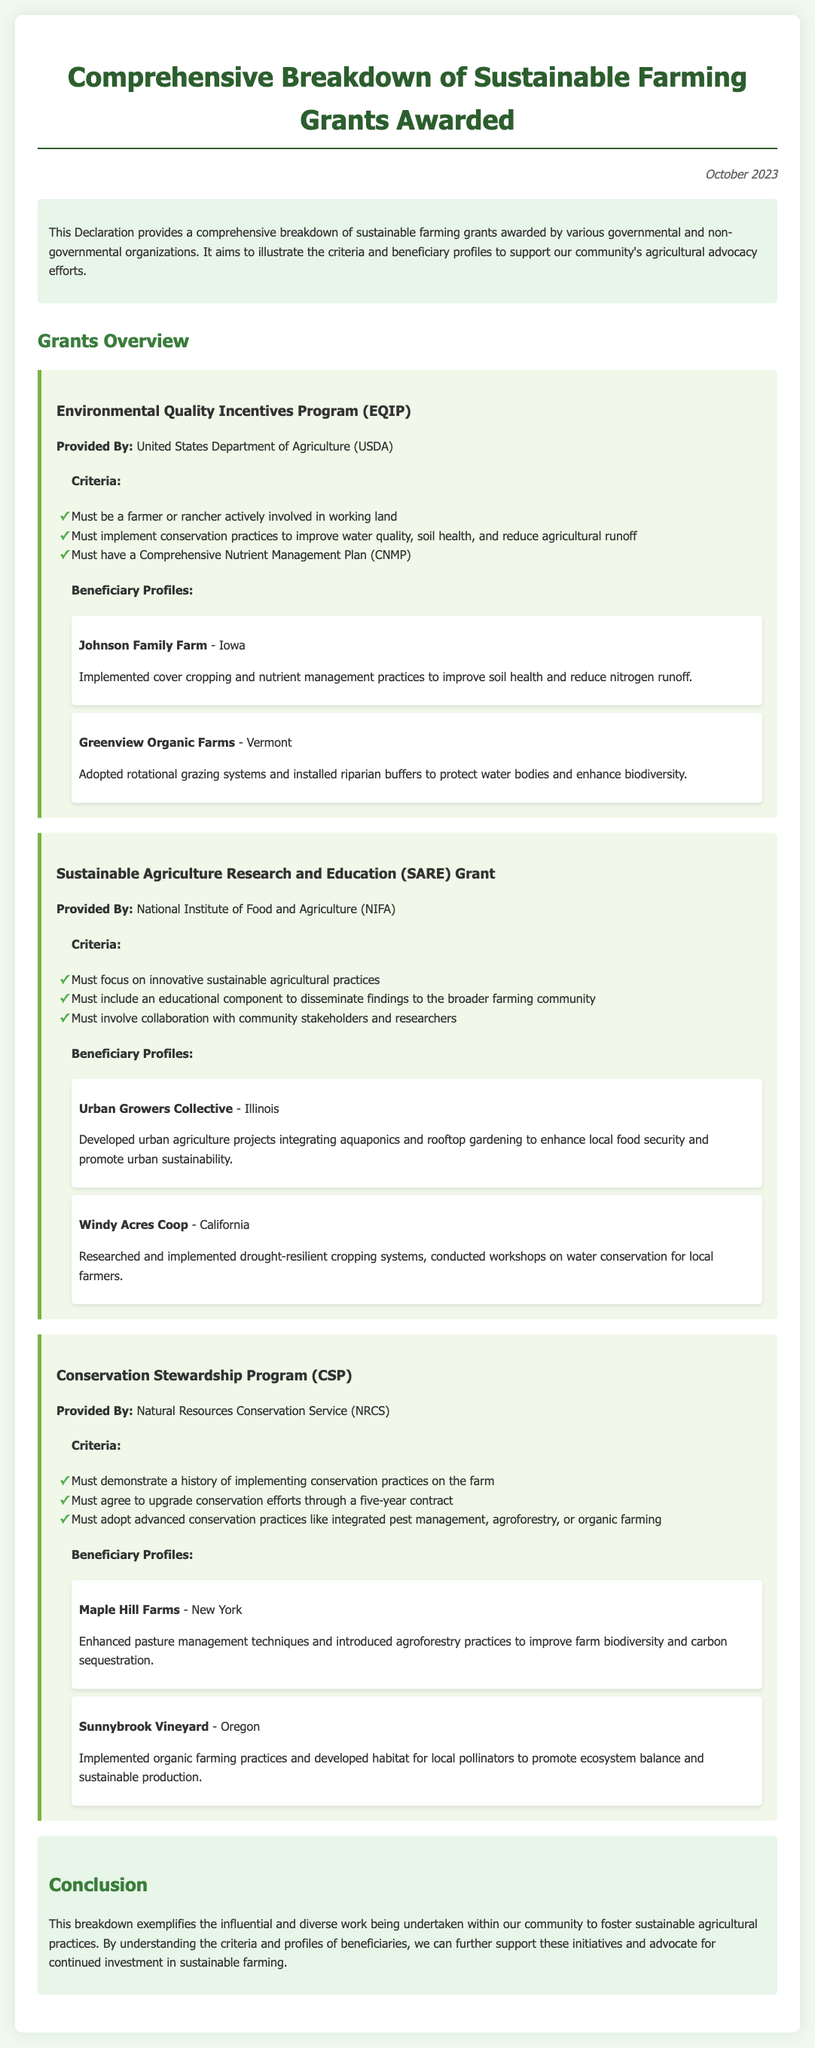What is the title of the document? The title is mentioned at the top of the document, identifying its primary focus.
Answer: Comprehensive Breakdown of Sustainable Farming Grants Awarded Which organization provides the Environmental Quality Incentives Program? This information is stated in the section detailing the funding source for the program.
Answer: United States Department of Agriculture (USDA) What is a criterion for the SARE Grant? The criteria outlined states specific requirements needed for grant eligibility.
Answer: Must focus on innovative sustainable agricultural practices How many beneficiary profiles are listed under the Conservation Stewardship Program? The document lists the number of beneficiaries under this program specifically.
Answer: Two Which farm in Iowa received funding for nutrient management practices? This farm is highlighted as a beneficiary with specific practices implemented in their operations.
Answer: Johnson Family Farm What advanced practices must CSP beneficiaries adopt? The document mentions specific practices that need to be adopted for this program.
Answer: integrated pest management, agroforestry, or organic farming What educational component is required for the SARE Grant? The requirements include an educational aspect integral to the grant's implementation.
Answer: disseminate findings to the broader farming community What conclusion is drawn regarding sustainable agricultural practices? The conclusion summarizes the purpose of the document and its motivation for further action.
Answer: continue support for these initiatives 